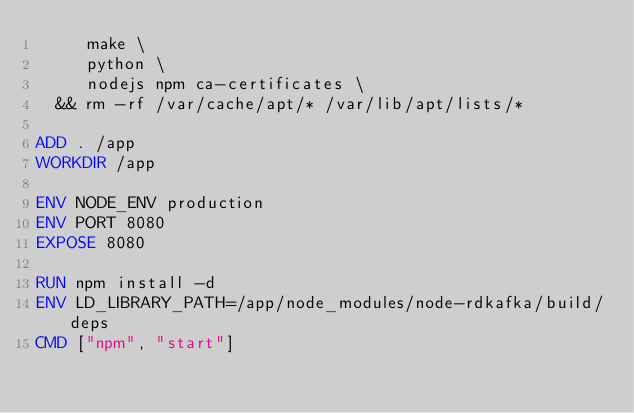<code> <loc_0><loc_0><loc_500><loc_500><_Dockerfile_>     make \
     python \
     nodejs npm ca-certificates \
  && rm -rf /var/cache/apt/* /var/lib/apt/lists/*

ADD . /app
WORKDIR /app

ENV NODE_ENV production
ENV PORT 8080
EXPOSE 8080

RUN npm install -d
ENV LD_LIBRARY_PATH=/app/node_modules/node-rdkafka/build/deps
CMD ["npm", "start"]
</code> 